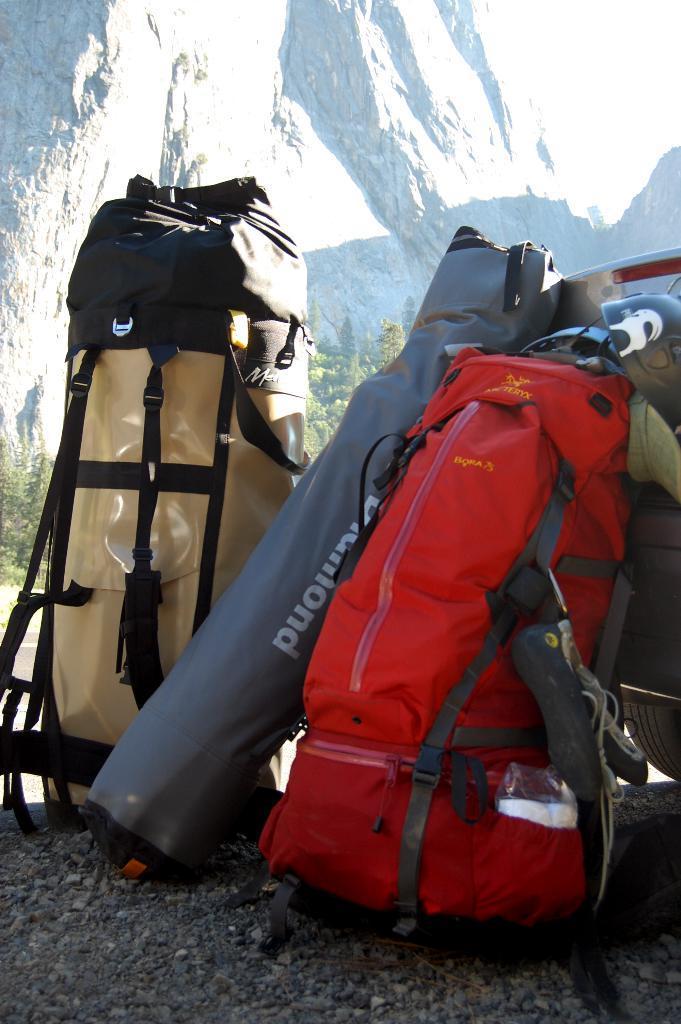Please provide a concise description of this image. In this image i can see three bags on the ground. 